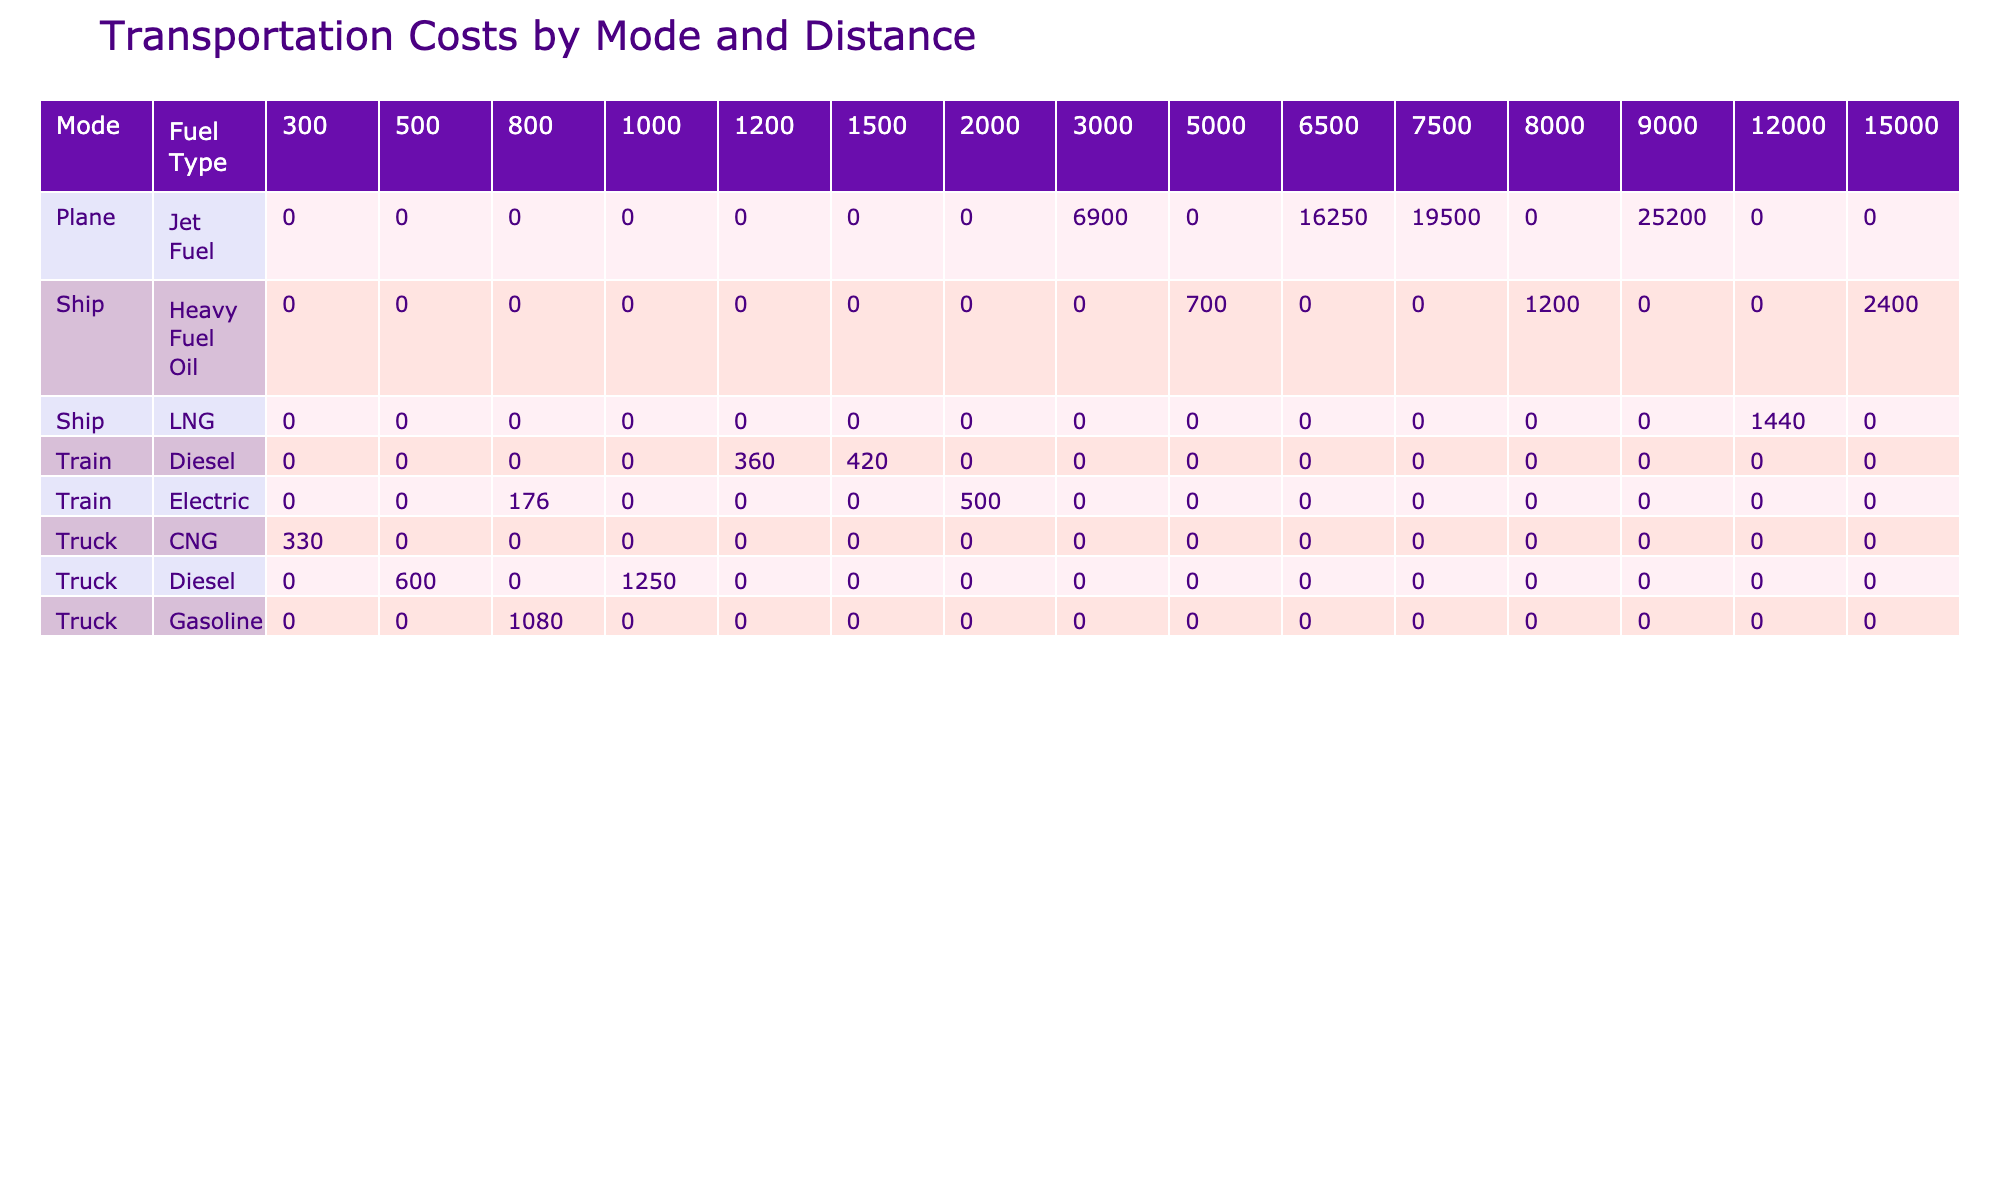What is the total cost of using a truck for 500 kilometers? The table shows that for a truck over a distance of 500 kilometers, the total cost is 600 dollars.
Answer: 600 dollars What is the total cost when using a plane for a distance of 9000 kilometers? Referring to the table, the total cost for a plane covering a distance of 9000 kilometers is 25,200 dollars.
Answer: 25,200 dollars Which mode of transport has the highest total cost? Looking at the total cost column, the mode with the highest total cost is the plane with a distance of 7500 kilometers, costing 19,500 dollars.
Answer: Plane What is the average fuel consumption for trains in liters per 100 kilometers? The fuel consumption for trains in the table shows values of 6, 5.5, and 0 (for electric trains). Thus, the average is (6 + 5.5 + 0)/2 = 5.75, excluding the electric train.
Answer: 5.75 liters per 100 kilometers Is the fuel consumption for the truck mode consistently higher than for the train mode across all distances? By examining the fuel consumption values for both modes, the truck mode shows fuel consumptions of 35, 40, 38, and 36 liters per 100 kilometers while the train mode has values of 6, 5.5, and 0 (electric). This indicates that truck fuel consumption is consistently higher than train consumption.
Answer: Yes What is the total cost of shipping 12000 kilometers with a ship? From the table, when shipping with a ship over a distance of 12000 kilometers, the total cost recorded is 1,440 dollars.
Answer: 1,440 dollars What is the difference in total costs between shipping by plane for 9000 kilometers and shipping by train for 1200 kilometers? The total cost for the plane at 9000 km is 25,200 dollars and for the train at 1200 km is 360 dollars. The difference is 25,200 - 360 = 24,840 dollars.
Answer: 24,840 dollars How many modes of transport have a fuel consumption of less than 5 liters per 100 kilometers? The table lists no modes of transport with a fuel consumption of less than 5 liters per 100 kilometers, as the lowest value recorded is 5.5 for the train type.
Answer: None Which transport mode had the lowest total cost and what was it? By reviewing the total costs for each mode of transport, the lowest total cost is 176 dollars for a train over 800 kilometers.
Answer: Train, 176 dollars 